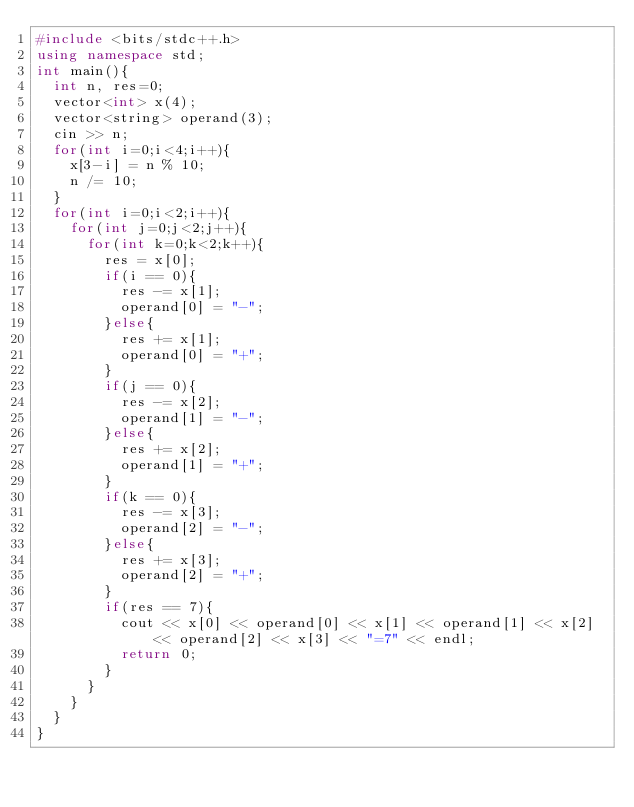<code> <loc_0><loc_0><loc_500><loc_500><_C++_>#include <bits/stdc++.h>
using namespace std;
int main(){
  int n, res=0;
  vector<int> x(4);
  vector<string> operand(3);
  cin >> n;
  for(int i=0;i<4;i++){
    x[3-i] = n % 10;
    n /= 10;
  }
  for(int i=0;i<2;i++){
    for(int j=0;j<2;j++){
      for(int k=0;k<2;k++){
        res = x[0];
        if(i == 0){
          res -= x[1];
          operand[0] = "-";
        }else{
          res += x[1];
          operand[0] = "+";
        }
        if(j == 0){
          res -= x[2];
          operand[1] = "-";
        }else{
          res += x[2];
          operand[1] = "+";
        }
        if(k == 0){
          res -= x[3];
          operand[2] = "-";
        }else{
          res += x[3];
          operand[2] = "+";
        }
        if(res == 7){
          cout << x[0] << operand[0] << x[1] << operand[1] << x[2] << operand[2] << x[3] << "=7" << endl;
          return 0;
        }
      }
    }
  }
}</code> 